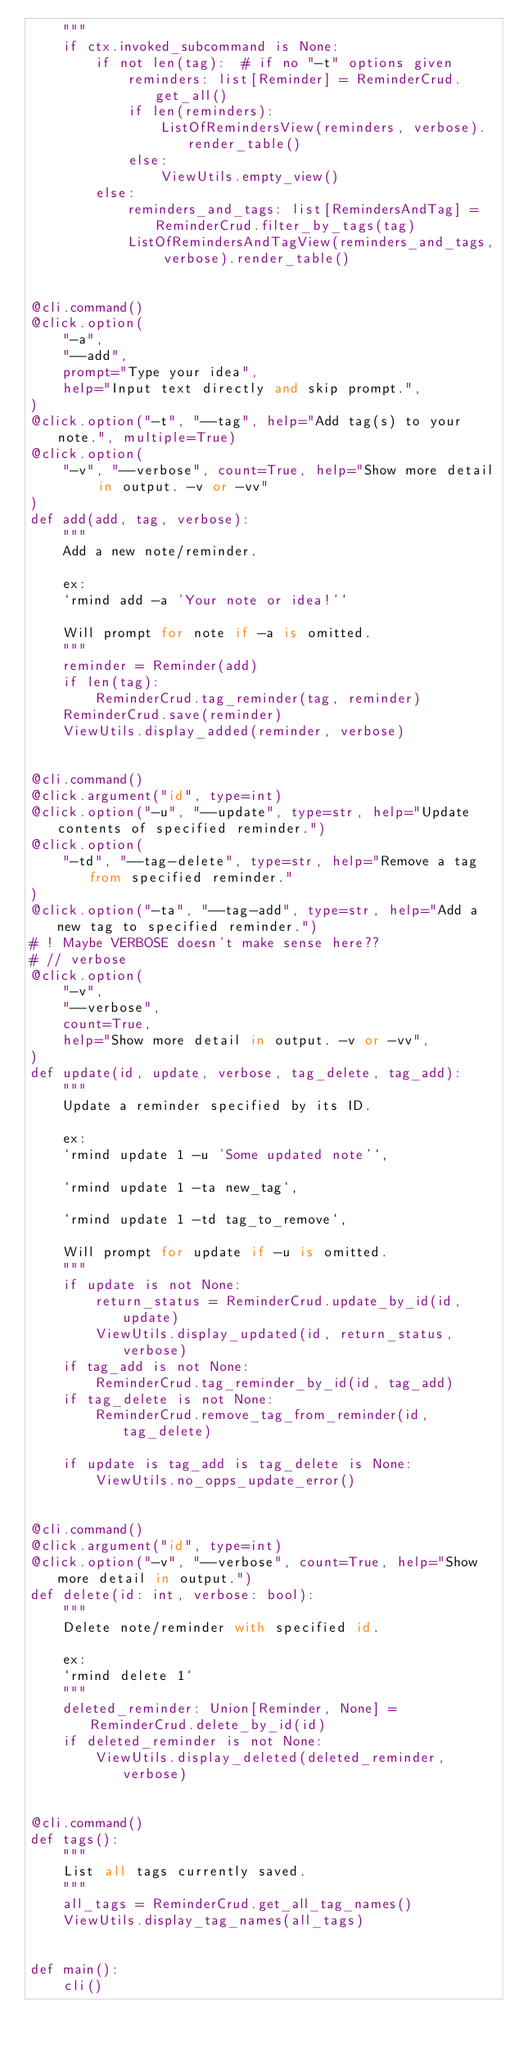Convert code to text. <code><loc_0><loc_0><loc_500><loc_500><_Python_>    """
    if ctx.invoked_subcommand is None:
        if not len(tag):  # if no "-t" options given
            reminders: list[Reminder] = ReminderCrud.get_all()
            if len(reminders):
                ListOfRemindersView(reminders, verbose).render_table()
            else:
                ViewUtils.empty_view()
        else:
            reminders_and_tags: list[RemindersAndTag] = ReminderCrud.filter_by_tags(tag)
            ListOfRemindersAndTagView(reminders_and_tags, verbose).render_table()


@cli.command()
@click.option(
    "-a",
    "--add",
    prompt="Type your idea",
    help="Input text directly and skip prompt.",
)
@click.option("-t", "--tag", help="Add tag(s) to your note.", multiple=True)
@click.option(
    "-v", "--verbose", count=True, help="Show more detail in output. -v or -vv"
)
def add(add, tag, verbose):
    """
    Add a new note/reminder.

    ex:
    `rmind add -a 'Your note or idea!'`

    Will prompt for note if -a is omitted.
    """
    reminder = Reminder(add)
    if len(tag):
        ReminderCrud.tag_reminder(tag, reminder)
    ReminderCrud.save(reminder)
    ViewUtils.display_added(reminder, verbose)


@cli.command()
@click.argument("id", type=int)
@click.option("-u", "--update", type=str, help="Update contents of specified reminder.")
@click.option(
    "-td", "--tag-delete", type=str, help="Remove a tag from specified reminder."
)
@click.option("-ta", "--tag-add", type=str, help="Add a new tag to specified reminder.")
# ! Maybe VERBOSE doesn't make sense here??
# // verbose
@click.option(
    "-v",
    "--verbose",
    count=True,
    help="Show more detail in output. -v or -vv",
)
def update(id, update, verbose, tag_delete, tag_add):
    """
    Update a reminder specified by its ID.

    ex:
    `rmind update 1 -u 'Some updated note'`,

    `rmind update 1 -ta new_tag`,

    `rmind update 1 -td tag_to_remove`,

    Will prompt for update if -u is omitted.
    """
    if update is not None:
        return_status = ReminderCrud.update_by_id(id, update)
        ViewUtils.display_updated(id, return_status, verbose)
    if tag_add is not None:
        ReminderCrud.tag_reminder_by_id(id, tag_add)
    if tag_delete is not None:
        ReminderCrud.remove_tag_from_reminder(id, tag_delete)

    if update is tag_add is tag_delete is None:
        ViewUtils.no_opps_update_error()


@cli.command()
@click.argument("id", type=int)
@click.option("-v", "--verbose", count=True, help="Show more detail in output.")
def delete(id: int, verbose: bool):
    """
    Delete note/reminder with specified id.

    ex:
    `rmind delete 1`
    """
    deleted_reminder: Union[Reminder, None] = ReminderCrud.delete_by_id(id)
    if deleted_reminder is not None:
        ViewUtils.display_deleted(deleted_reminder, verbose)


@cli.command()
def tags():
    """
    List all tags currently saved.
    """
    all_tags = ReminderCrud.get_all_tag_names()
    ViewUtils.display_tag_names(all_tags)


def main():
    cli()</code> 